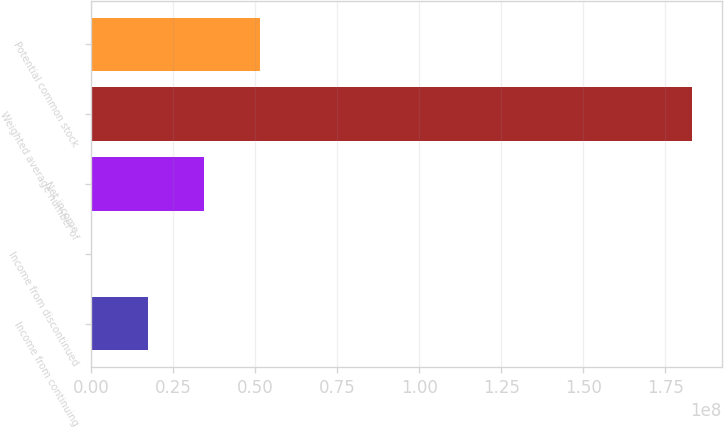Convert chart. <chart><loc_0><loc_0><loc_500><loc_500><bar_chart><fcel>Income from continuing<fcel>Income from discontinued<fcel>Net income<fcel>Weighted average number of<fcel>Potential common stock<nl><fcel>1.71815e+07<fcel>11679<fcel>3.43512e+07<fcel>1.8306e+08<fcel>5.1521e+07<nl></chart> 